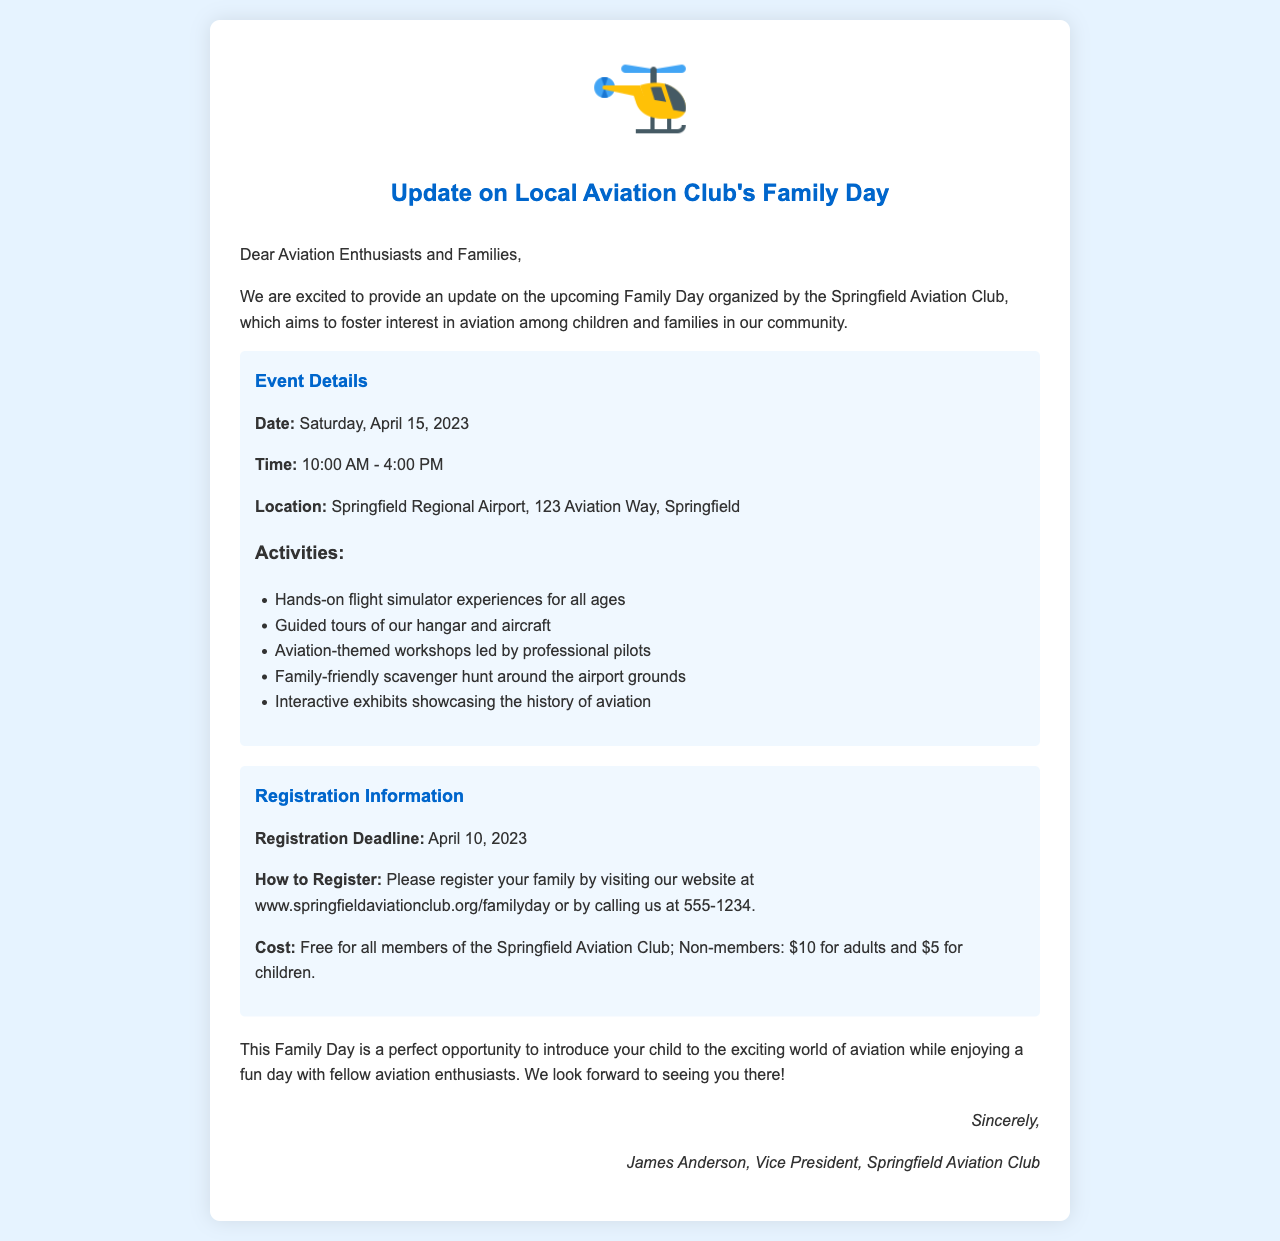What is the date of the Family Day? The date is provided in the event details section, which states that the Family Day will take place on Saturday, April 15, 2023.
Answer: April 15, 2023 What is the location of the event? The document specifies the location as Springfield Regional Airport, 123 Aviation Way, Springfield.
Answer: Springfield Regional Airport What time does the event start? The event schedule indicates that the Family Day starts at 10:00 AM.
Answer: 10:00 AM How much does it cost for non-member adults? The registration information states that non-member adults will need to pay $10.
Answer: $10 What type of activities are available at the event? The document lists several activities, including hands-on flight simulator experiences, guided tours, aviation-themed workshops, scavenger hunts, and interactive exhibits.
Answer: Hands-on flight simulator experiences, guided tours, aviation-themed workshops, scavenger hunt, interactive exhibits When is the registration deadline? The registration information specifies that the deadline is April 10, 2023.
Answer: April 10, 2023 How can families register for the event? The document outlines that families can register by visiting the website or calling the provided phone number.
Answer: Website or calling 555-1234 Who is the sender of the letter? The signature at the end of the document indicates that it is from James Anderson, Vice President of Springfield Aviation Club.
Answer: James Anderson 